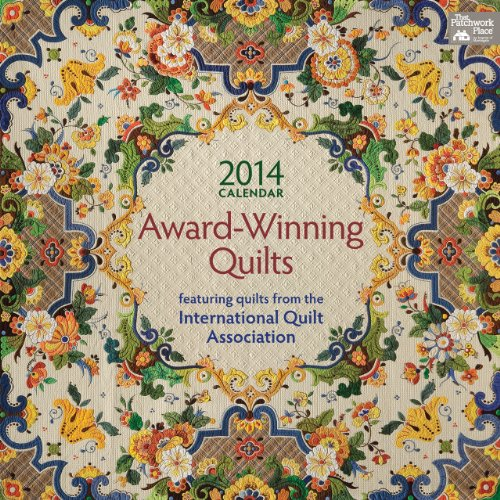What is the genre of this book? This book belongs to the genre of calendars, specifically themed around award-winning quilts from various competitions. 